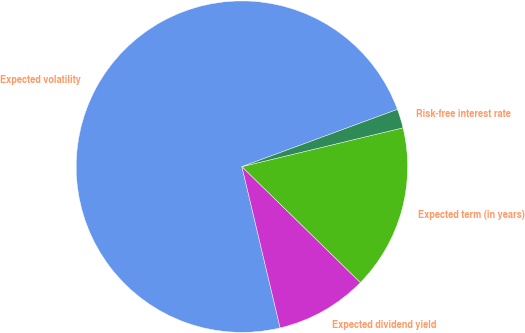Convert chart to OTSL. <chart><loc_0><loc_0><loc_500><loc_500><pie_chart><fcel>Expected volatility<fcel>Expected dividend yield<fcel>Expected term (in years)<fcel>Risk-free interest rate<nl><fcel>73.09%<fcel>8.97%<fcel>16.09%<fcel>1.85%<nl></chart> 